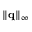Convert formula to latex. <formula><loc_0><loc_0><loc_500><loc_500>{ { { \left \| { q } \right \| } _ { \infty } } }</formula> 